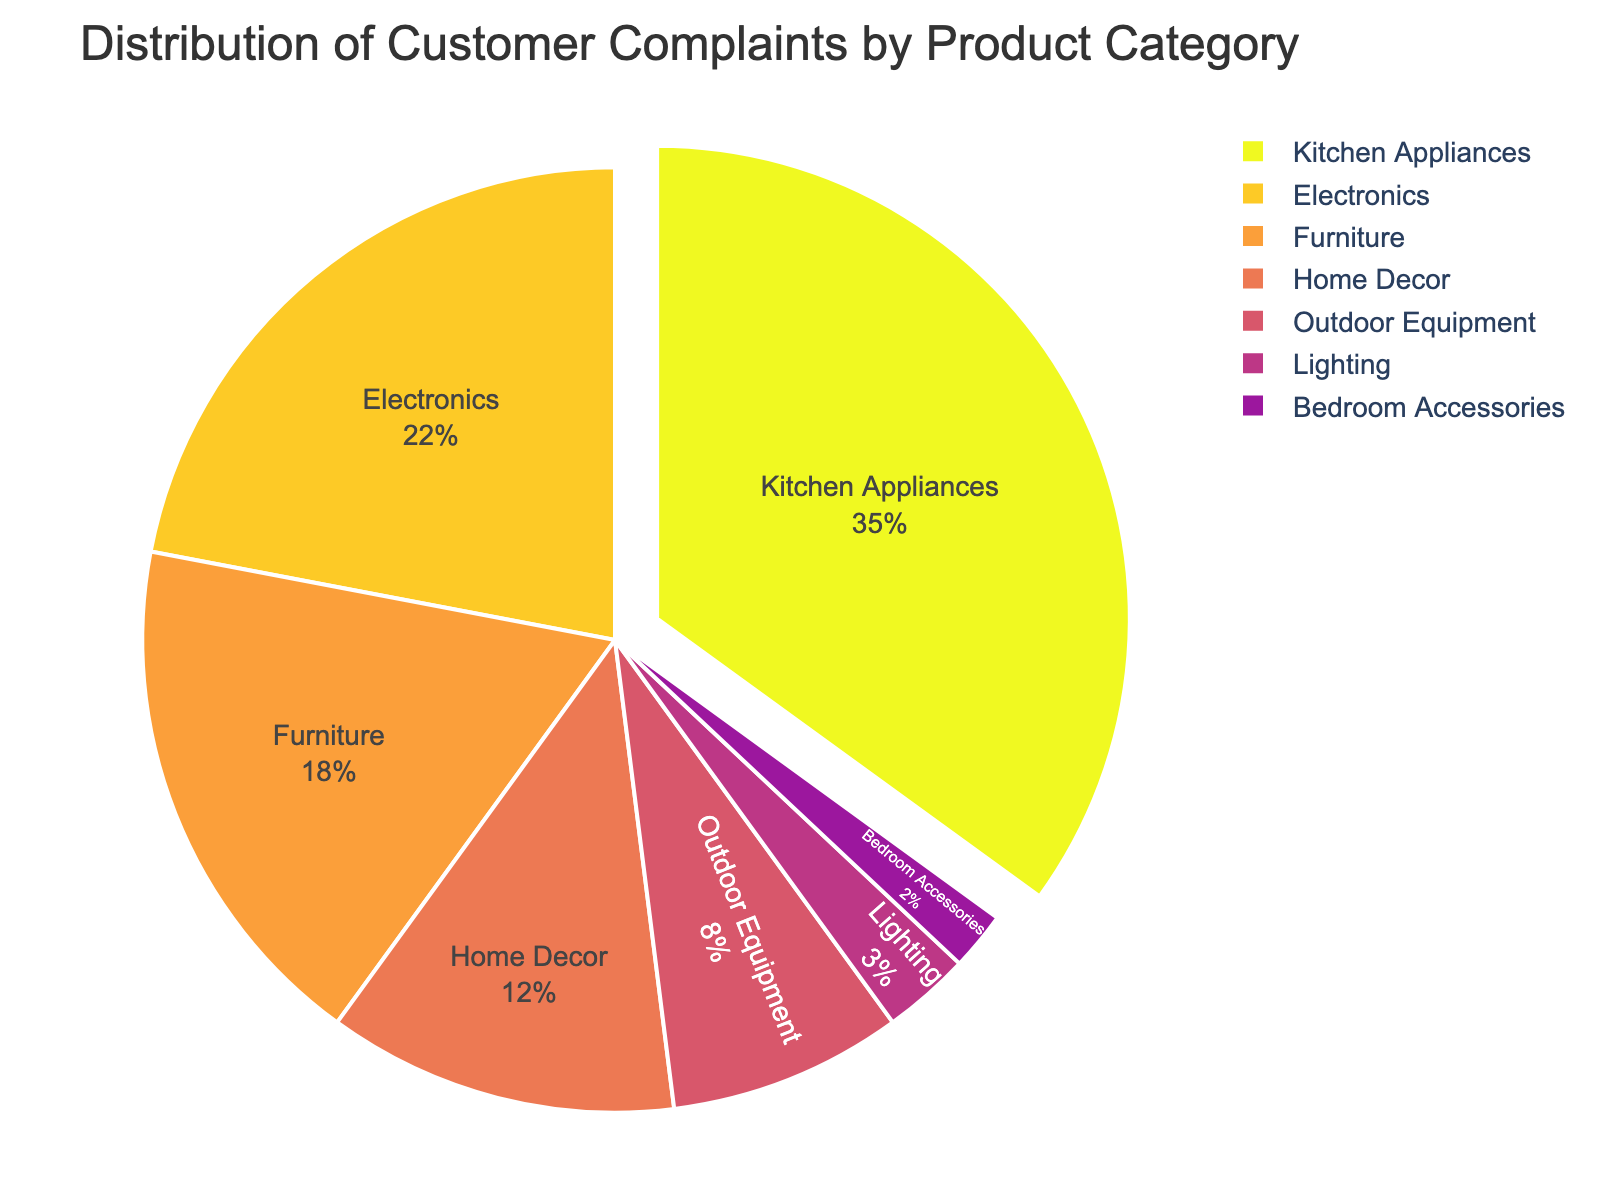What percentage of complaints are attributed to Kitchen Appliances? The pie chart shows that Kitchen Appliances make up 35% of the complaints, which is displayed directly on the chart.
Answer: 35% Which product category has the least complaints? The pie chart shows that Bedroom Accessories have the smallest slice and their share is 2%, making them the category with the least complaints.
Answer: Bedroom Accessories How many percentage points more do Kitchen Appliances have compared to Electronics? Kitchen Appliances have 35% of the complaints, while Electronics have 22%. The difference in percentage points is 35% - 22% = 13%.
Answer: 13% Are there more complaints for Home Decor than for Outdoor Equipment? The pie chart shows that Home Decor has 12% of the complaints and Outdoor Equipment has 8%, so Home Decor has more complaints.
Answer: Yes What is the combined percentage of complaints for Electronics and Furniture? According to the pie chart, Electronics have 22% and Furniture have 18%. The combined percentage is 22% + 18% = 40%.
Answer: 40% What visual feature highlights the category with the highest complaints? The pie chart visually pulls out the slice for Kitchen Appliances, which has the highest complaints at 35%.
Answer: Pulled out slice How do the complaints for Furniture compare to those for Home Decor? The chart shows that Furniture accounts for 18% of the complaints while Home Decor accounts for 12%. Therefore, Furniture has a higher percentage of complaints than Home Decor.
Answer: Furniture has more complaints Which two categories contribute to just over a quarter of all complaints combined? The pie chart shows that Outdoor Equipment and Home Decor account for 8% and 12% of the complaints, respectively. Together, they contribute 8% + 12% = 20%, which is just under a quarter. Adding Lighting with 3% gives 23%, which is just under a quarter. Adding Bedroom Accessories with 2% gives 25%. Therefore, Home Decor and Outdoor Equipment with Lighting and Bedroom Accessories contribute just over a quarter.
Answer: Home Decor and Outdoor Equipment What is the percentage of complaints for categories outside of Kitchen Appliances and Electronics? First, sum the percentages for Kitchen Appliances and Electronics: 35% + 22% = 57%. Then, subtract this from 100%: 100% - 57% = 43%.
Answer: 43% Which three categories combine to form slightly more than half of all complaints? From the pie chart, the largest categories are Kitchen Appliances (35%), Electronics (22%), and Furniture (18%). Combining these: 35% + 22% + 18% = 75%, which is more than half.
Answer: Kitchen Appliances, Electronics, and Furniture 